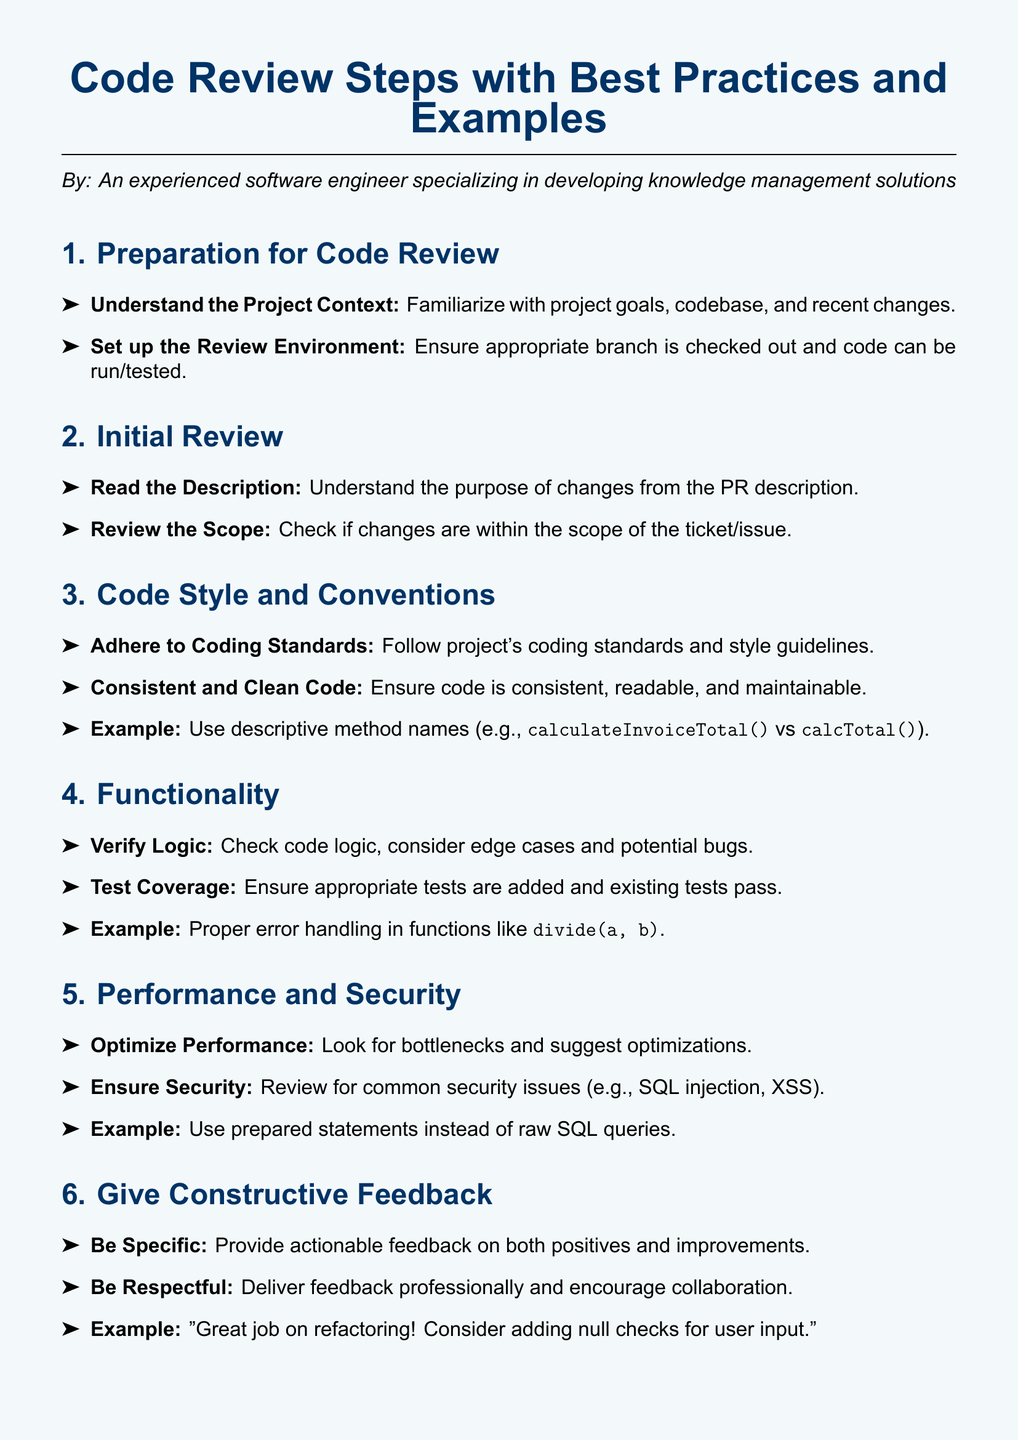What is the first step in the code review process? The first step outlined in the document is "Preparation for Code Review."
Answer: Preparation for Code Review What is emphasized in the "Code Style and Conventions" section? This section emphasizes adherence to coding standards and style guidelines.
Answer: Adhere to Coding Standards What should be documented after a code review? The document states that all comments and decisions should be documented for future reference.
Answer: Document Comments What is an example of ensuring security in code? The document suggests using prepared statements instead of raw SQL queries.
Answer: Prepared statements What aspect should be verified in the "Functionality" section? The focus in this section is on verifying the logic and considering edge cases.
Answer: Verify Logic How should feedback be delivered according to the best practices? The best practice suggests delivering feedback professionally and encouraging collaboration.
Answer: Be Respectful What should be checked regarding test coverage? It is important to ensure that appropriate tests are added and existing tests pass.
Answer: Test Coverage What is the overall purpose of the code review steps? The document provides a structured approach to conducting effective code reviews.
Answer: Effective code reviews What should reviewers familiarize themselves with during preparation? Reviewers should familiarize themselves with project goals, codebase, and recent changes.
Answer: Project Goals 